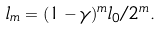Convert formula to latex. <formula><loc_0><loc_0><loc_500><loc_500>l _ { m } = ( 1 - \gamma ) ^ { m } l _ { 0 } / 2 ^ { m } .</formula> 